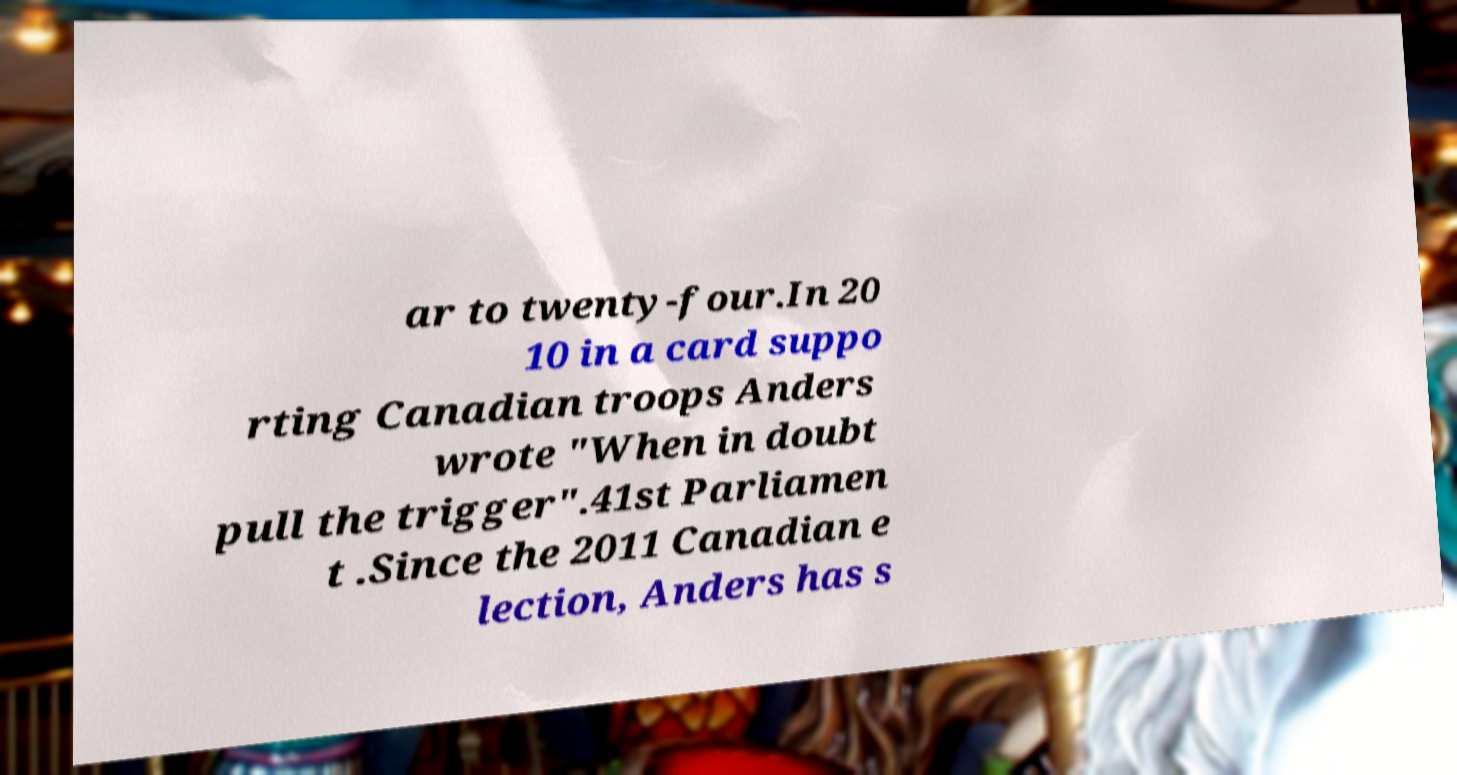What messages or text are displayed in this image? I need them in a readable, typed format. ar to twenty-four.In 20 10 in a card suppo rting Canadian troops Anders wrote "When in doubt pull the trigger".41st Parliamen t .Since the 2011 Canadian e lection, Anders has s 